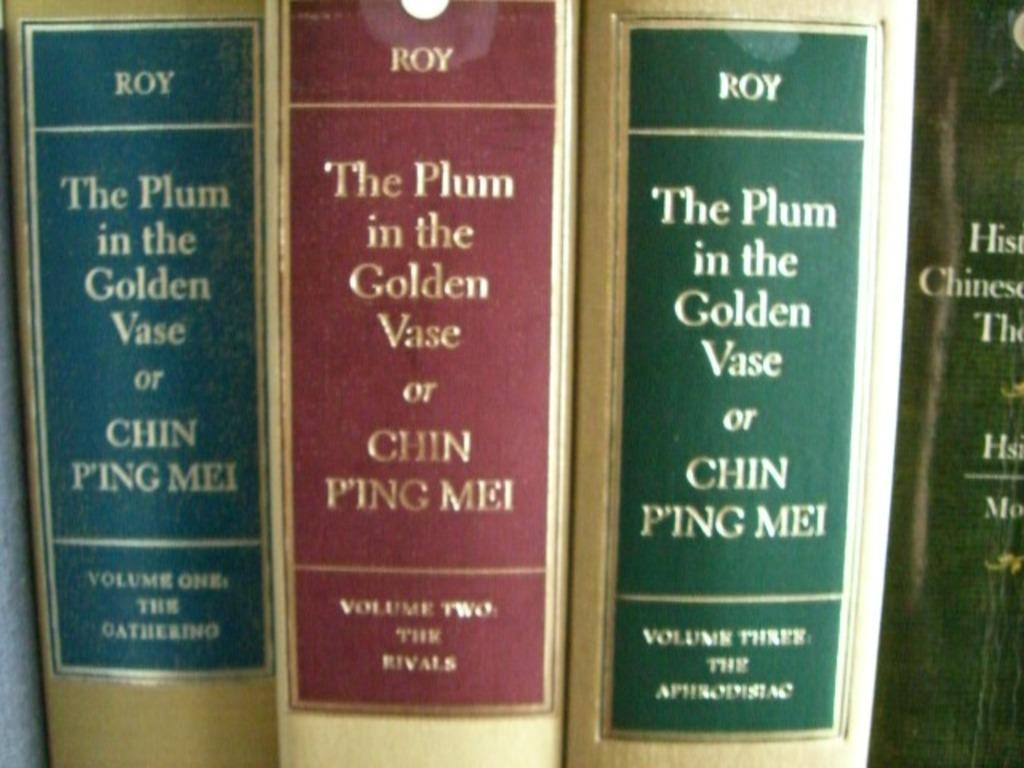What objects are present in the image? There are books in the image. What can be found on the books? The books have text on them. What type of berry is being sold at the market in the image? There is no market or berry present in the image; it only features books with text on them. 